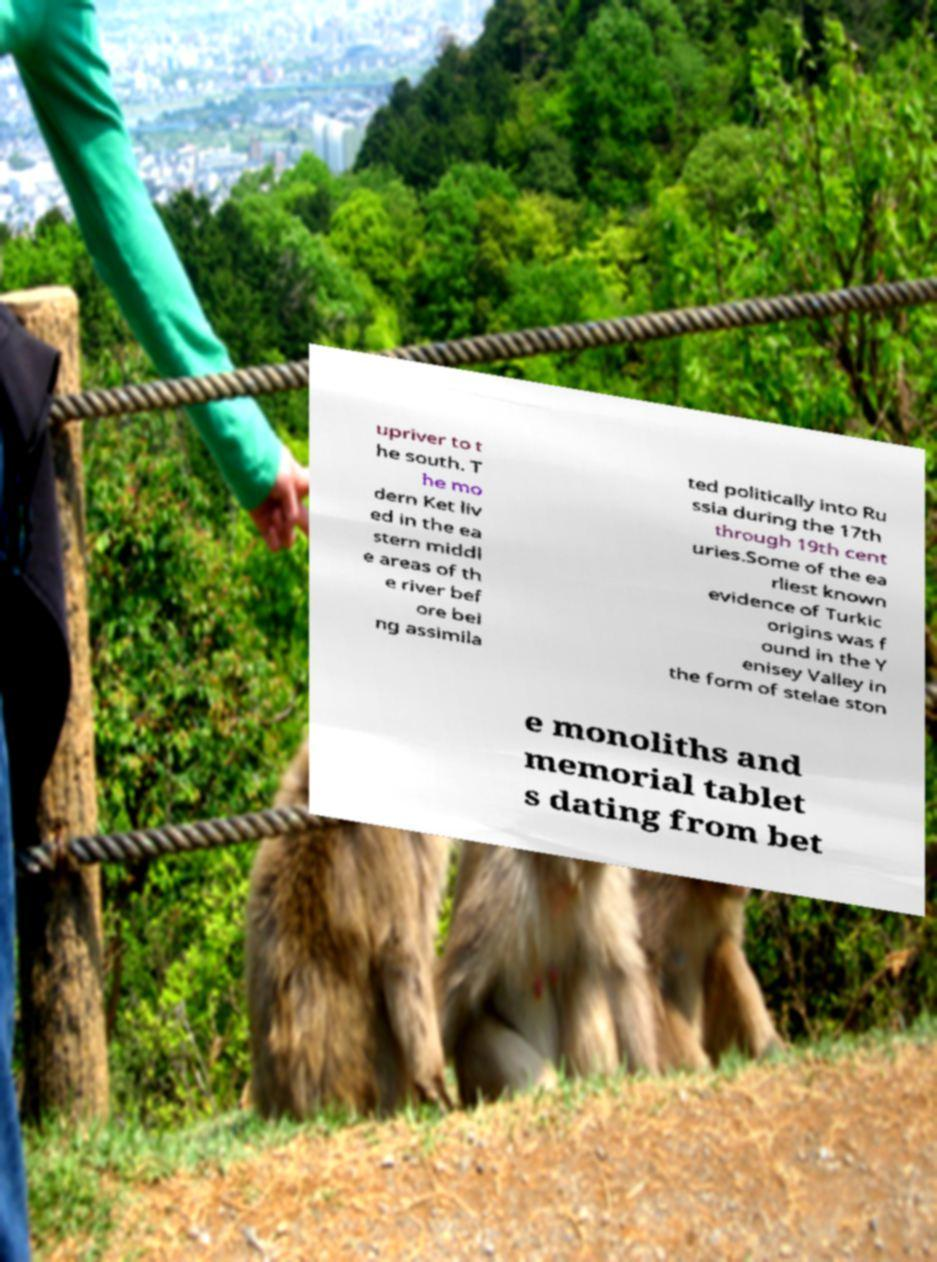Please identify and transcribe the text found in this image. upriver to t he south. T he mo dern Ket liv ed in the ea stern middl e areas of th e river bef ore bei ng assimila ted politically into Ru ssia during the 17th through 19th cent uries.Some of the ea rliest known evidence of Turkic origins was f ound in the Y enisey Valley in the form of stelae ston e monoliths and memorial tablet s dating from bet 